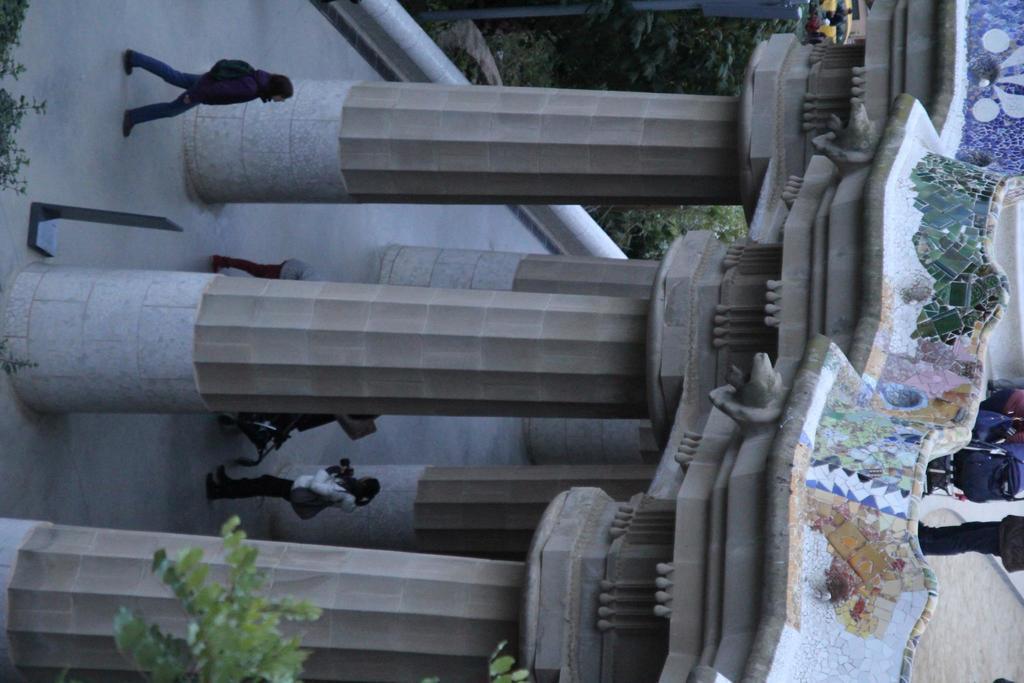Could you give a brief overview of what you see in this image? In the foreground of this image, there are persons walking on the ground and a building is also present. On right side of the image, there are persons standing on the top of the building. On the bottom side of the image, there is a tree and on the top side, there are trees. 